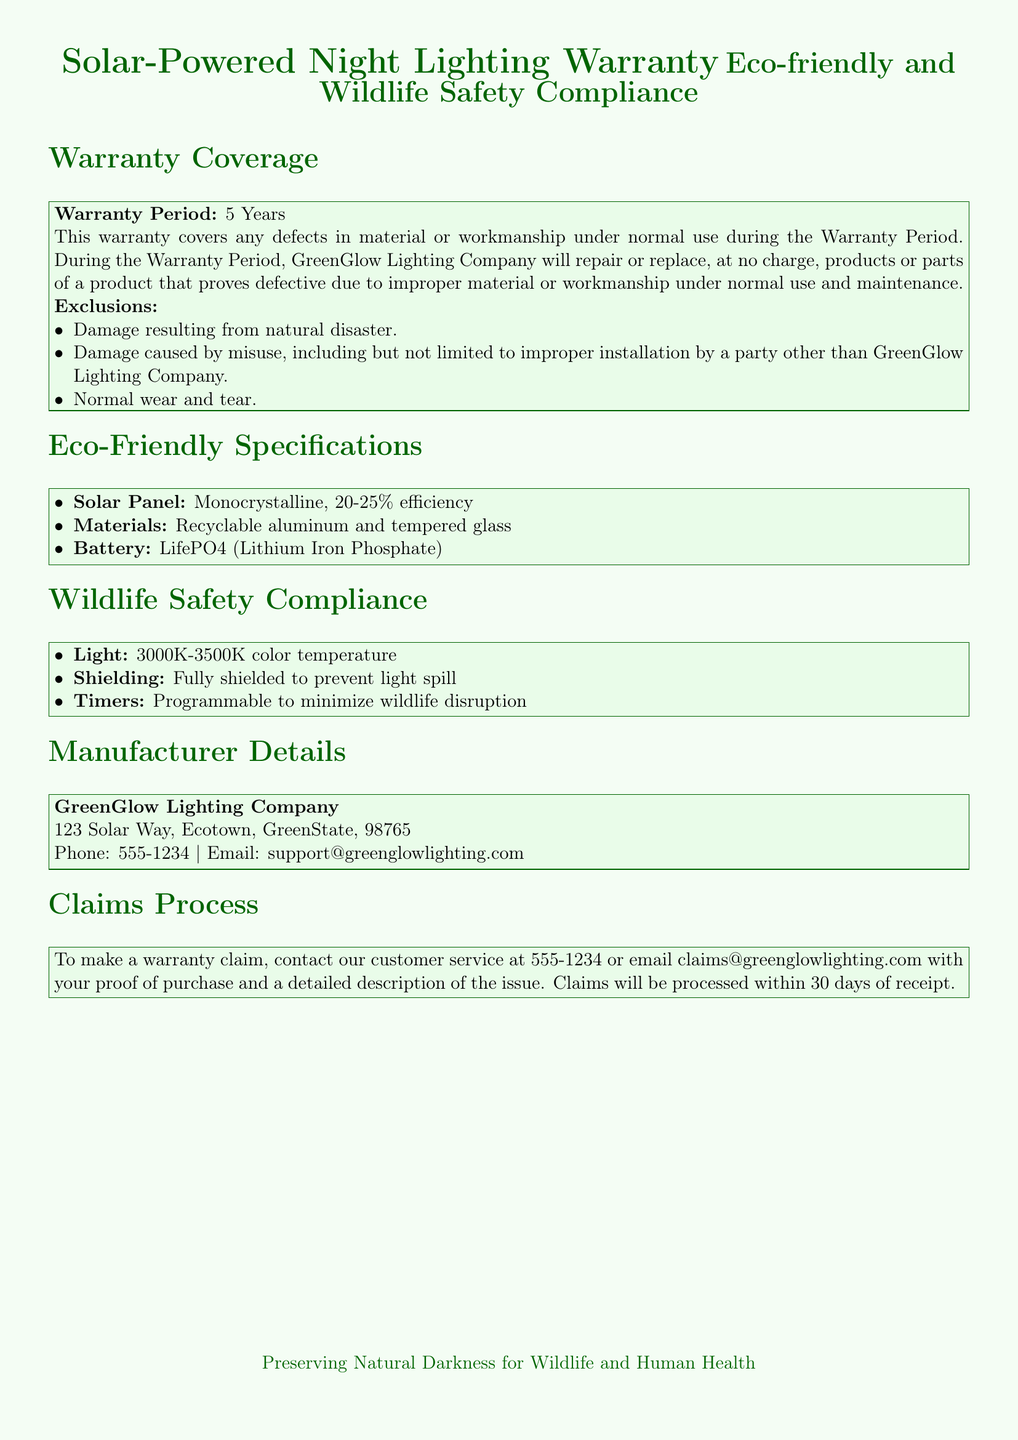what is the warranty period for the solar-powered night lighting? The warranty period is specified in the document under "Warranty Coverage" which states it is 5 years.
Answer: 5 Years what types of materials are used in the solar-powered night lighting? The document lists the eco-friendly specifications, including materials such as recyclable aluminum and tempered glass.
Answer: recyclable aluminum and tempered glass what is the efficiency range of the solar panel mentioned? The solar panel's efficiency range is provided in the eco-friendly specifications section stating it is 20-25%.
Answer: 20-25% what specific light color temperature is used for wildlife safety compliance? The document indicates the color temperature of the light to be 3000K-3500K under the wildlife safety compliance section.
Answer: 3000K-3500K who is the manufacturer of the solar-powered night lighting? The document provides the manufacturer details at the end, identifying the company as GreenGlow Lighting Company.
Answer: GreenGlow Lighting Company what type of battery is used in the solar-powered night lighting? The eco-friendly specifications section states that the battery used is LifePO4 (Lithium Iron Phosphate).
Answer: LifePO4 (Lithium Iron Phosphate) how long does it take to process a warranty claim? The claims process section mentions that claims will be processed within 30 days of receipt.
Answer: 30 days what does the shielding ensure for the lighting product? The wildlife safety compliance section states that fully shielded lighting prevents light spill, which is crucial for wildlife safety.
Answer: prevent light spill what is required to make a warranty claim? The document specifies that proof of purchase and a detailed description of the issue is required to make a claim.
Answer: proof of purchase and a detailed description of the issue 